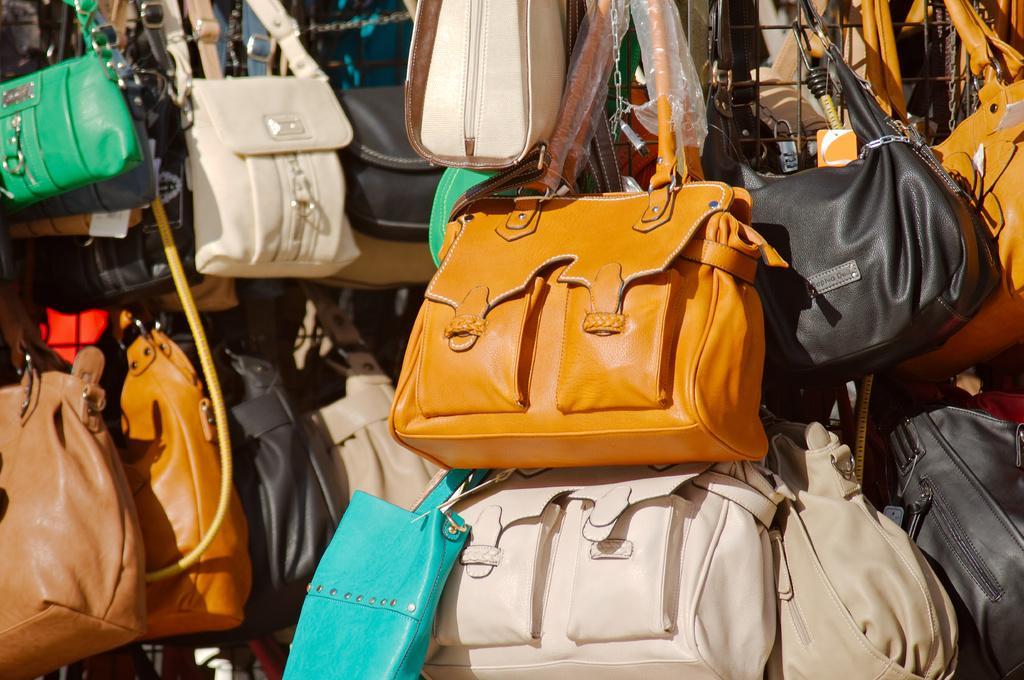How would you summarize this image in a sentence or two? This image consists of many handbags in different colors. In the front, we can see brown, white, green, blue and black colors. 